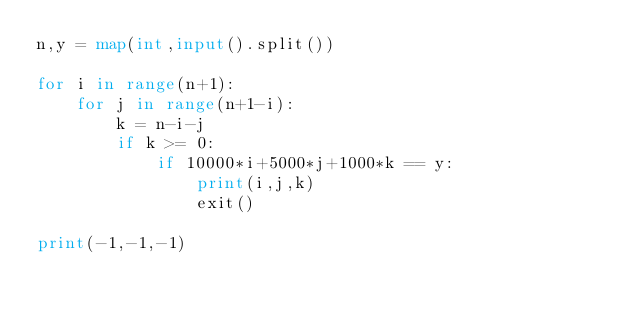<code> <loc_0><loc_0><loc_500><loc_500><_Python_>n,y = map(int,input().split())

for i in range(n+1):
    for j in range(n+1-i):
        k = n-i-j
        if k >= 0:
            if 10000*i+5000*j+1000*k == y:
                print(i,j,k)
                exit()

print(-1,-1,-1)</code> 